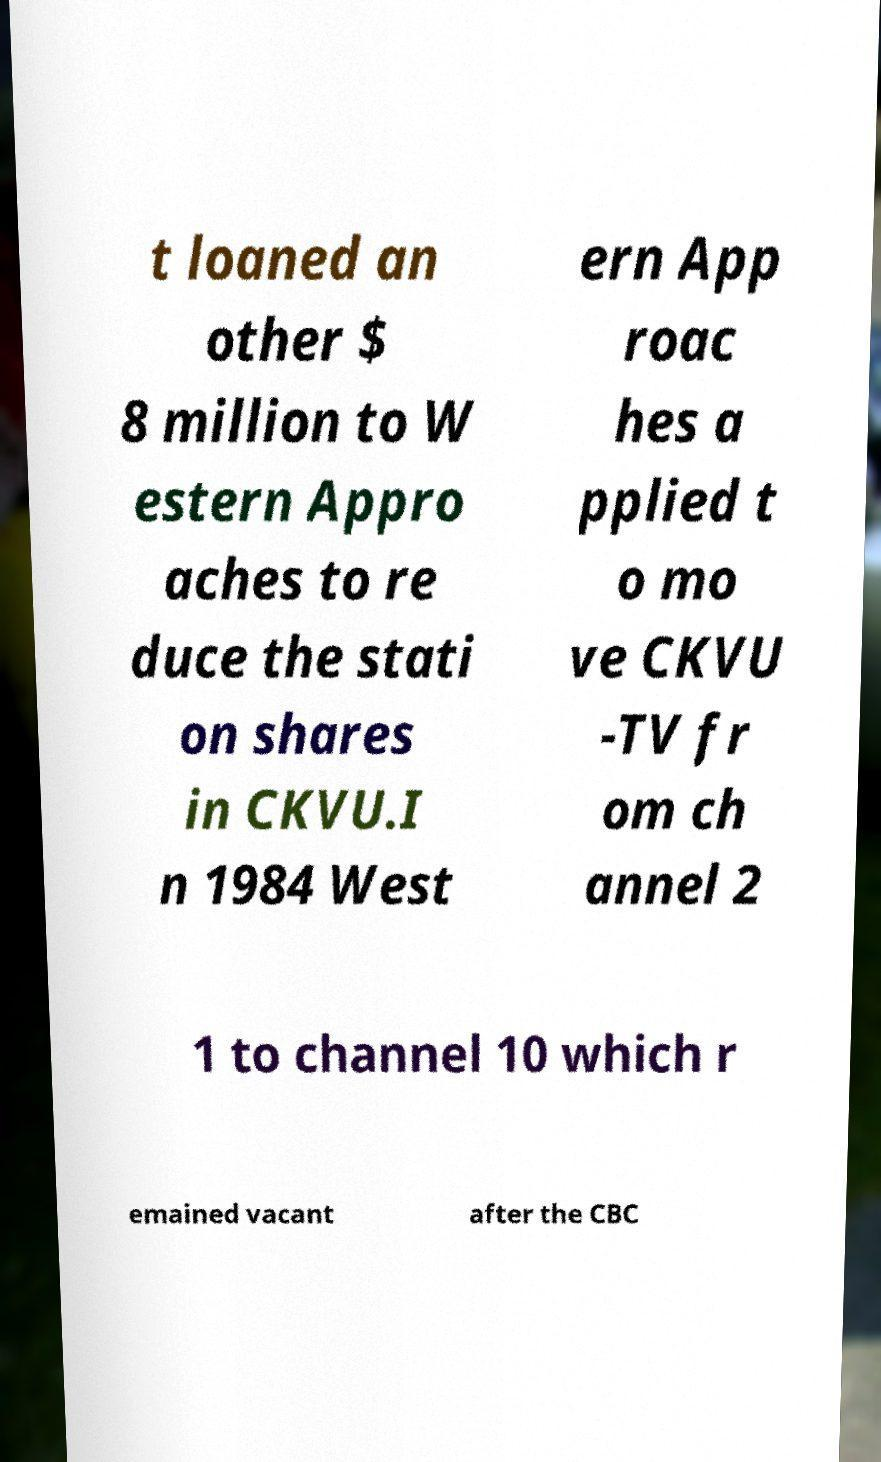I need the written content from this picture converted into text. Can you do that? t loaned an other $ 8 million to W estern Appro aches to re duce the stati on shares in CKVU.I n 1984 West ern App roac hes a pplied t o mo ve CKVU -TV fr om ch annel 2 1 to channel 10 which r emained vacant after the CBC 